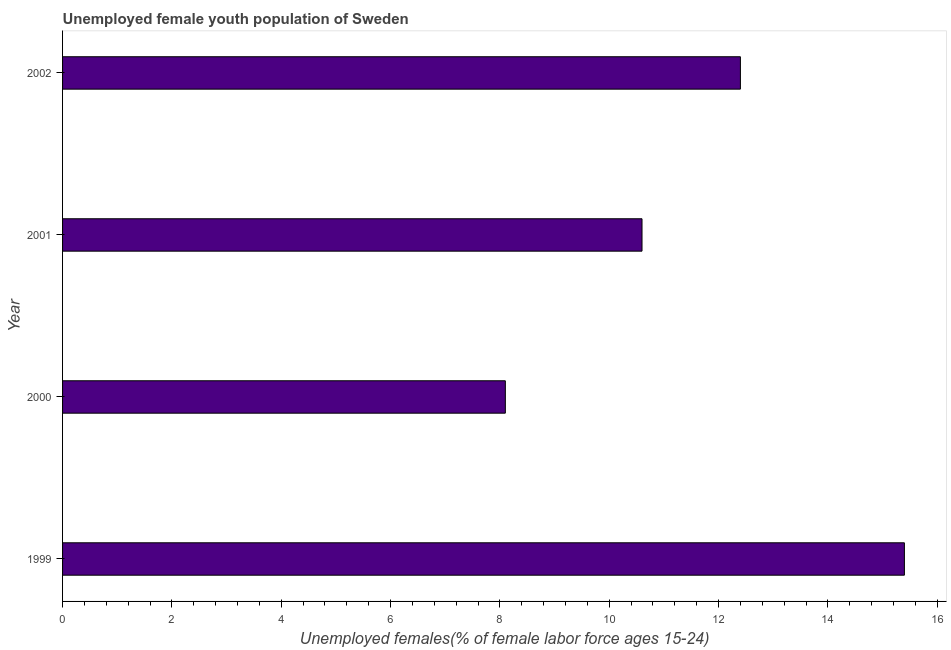Does the graph contain any zero values?
Provide a short and direct response. No. What is the title of the graph?
Offer a very short reply. Unemployed female youth population of Sweden. What is the label or title of the X-axis?
Your response must be concise. Unemployed females(% of female labor force ages 15-24). What is the label or title of the Y-axis?
Ensure brevity in your answer.  Year. What is the unemployed female youth in 1999?
Provide a short and direct response. 15.4. Across all years, what is the maximum unemployed female youth?
Offer a very short reply. 15.4. Across all years, what is the minimum unemployed female youth?
Make the answer very short. 8.1. What is the sum of the unemployed female youth?
Provide a short and direct response. 46.5. What is the average unemployed female youth per year?
Your response must be concise. 11.62. In how many years, is the unemployed female youth greater than 3.2 %?
Provide a short and direct response. 4. Do a majority of the years between 2000 and 2001 (inclusive) have unemployed female youth greater than 6 %?
Give a very brief answer. Yes. What is the ratio of the unemployed female youth in 1999 to that in 2000?
Ensure brevity in your answer.  1.9. Is the unemployed female youth in 2000 less than that in 2002?
Your answer should be very brief. Yes. Is the difference between the unemployed female youth in 2001 and 2002 greater than the difference between any two years?
Offer a terse response. No. What is the difference between the highest and the second highest unemployed female youth?
Keep it short and to the point. 3. Is the sum of the unemployed female youth in 1999 and 2002 greater than the maximum unemployed female youth across all years?
Keep it short and to the point. Yes. What is the difference between the highest and the lowest unemployed female youth?
Your answer should be compact. 7.3. How many years are there in the graph?
Offer a very short reply. 4. Are the values on the major ticks of X-axis written in scientific E-notation?
Make the answer very short. No. What is the Unemployed females(% of female labor force ages 15-24) in 1999?
Give a very brief answer. 15.4. What is the Unemployed females(% of female labor force ages 15-24) of 2000?
Ensure brevity in your answer.  8.1. What is the Unemployed females(% of female labor force ages 15-24) in 2001?
Give a very brief answer. 10.6. What is the Unemployed females(% of female labor force ages 15-24) in 2002?
Your response must be concise. 12.4. What is the difference between the Unemployed females(% of female labor force ages 15-24) in 1999 and 2000?
Offer a very short reply. 7.3. What is the difference between the Unemployed females(% of female labor force ages 15-24) in 1999 and 2001?
Offer a very short reply. 4.8. What is the difference between the Unemployed females(% of female labor force ages 15-24) in 2000 and 2001?
Make the answer very short. -2.5. What is the ratio of the Unemployed females(% of female labor force ages 15-24) in 1999 to that in 2000?
Provide a short and direct response. 1.9. What is the ratio of the Unemployed females(% of female labor force ages 15-24) in 1999 to that in 2001?
Make the answer very short. 1.45. What is the ratio of the Unemployed females(% of female labor force ages 15-24) in 1999 to that in 2002?
Provide a succinct answer. 1.24. What is the ratio of the Unemployed females(% of female labor force ages 15-24) in 2000 to that in 2001?
Make the answer very short. 0.76. What is the ratio of the Unemployed females(% of female labor force ages 15-24) in 2000 to that in 2002?
Your answer should be compact. 0.65. What is the ratio of the Unemployed females(% of female labor force ages 15-24) in 2001 to that in 2002?
Keep it short and to the point. 0.85. 